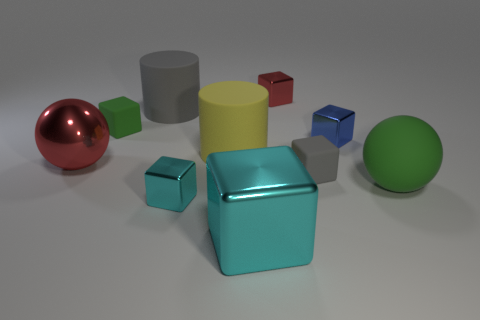Do the big rubber ball and the metallic thing to the right of the small red block have the same color?
Give a very brief answer. No. How many objects are small shiny spheres or small metallic objects?
Your answer should be very brief. 3. Are there any other things that have the same color as the large cube?
Give a very brief answer. Yes. Is the large cyan block made of the same material as the big cylinder in front of the small blue object?
Your response must be concise. No. There is a red thing that is right of the cylinder that is in front of the green rubber cube; what is its shape?
Your response must be concise. Cube. What is the shape of the big matte thing that is both in front of the big gray rubber object and to the left of the blue metal cube?
Your answer should be compact. Cylinder. What number of objects are yellow things or green matte blocks that are behind the large metallic sphere?
Your answer should be very brief. 2. What material is the other big object that is the same shape as the yellow rubber thing?
Keep it short and to the point. Rubber. Is there any other thing that is made of the same material as the big red ball?
Your answer should be very brief. Yes. The big thing that is both in front of the big red ball and left of the large green rubber object is made of what material?
Your answer should be very brief. Metal. 